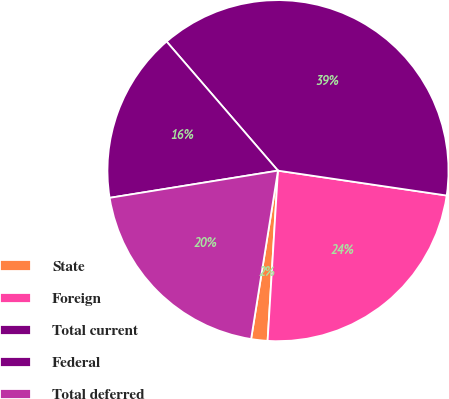Convert chart to OTSL. <chart><loc_0><loc_0><loc_500><loc_500><pie_chart><fcel>State<fcel>Foreign<fcel>Total current<fcel>Federal<fcel>Total deferred<nl><fcel>1.55%<fcel>23.64%<fcel>38.66%<fcel>16.22%<fcel>19.93%<nl></chart> 